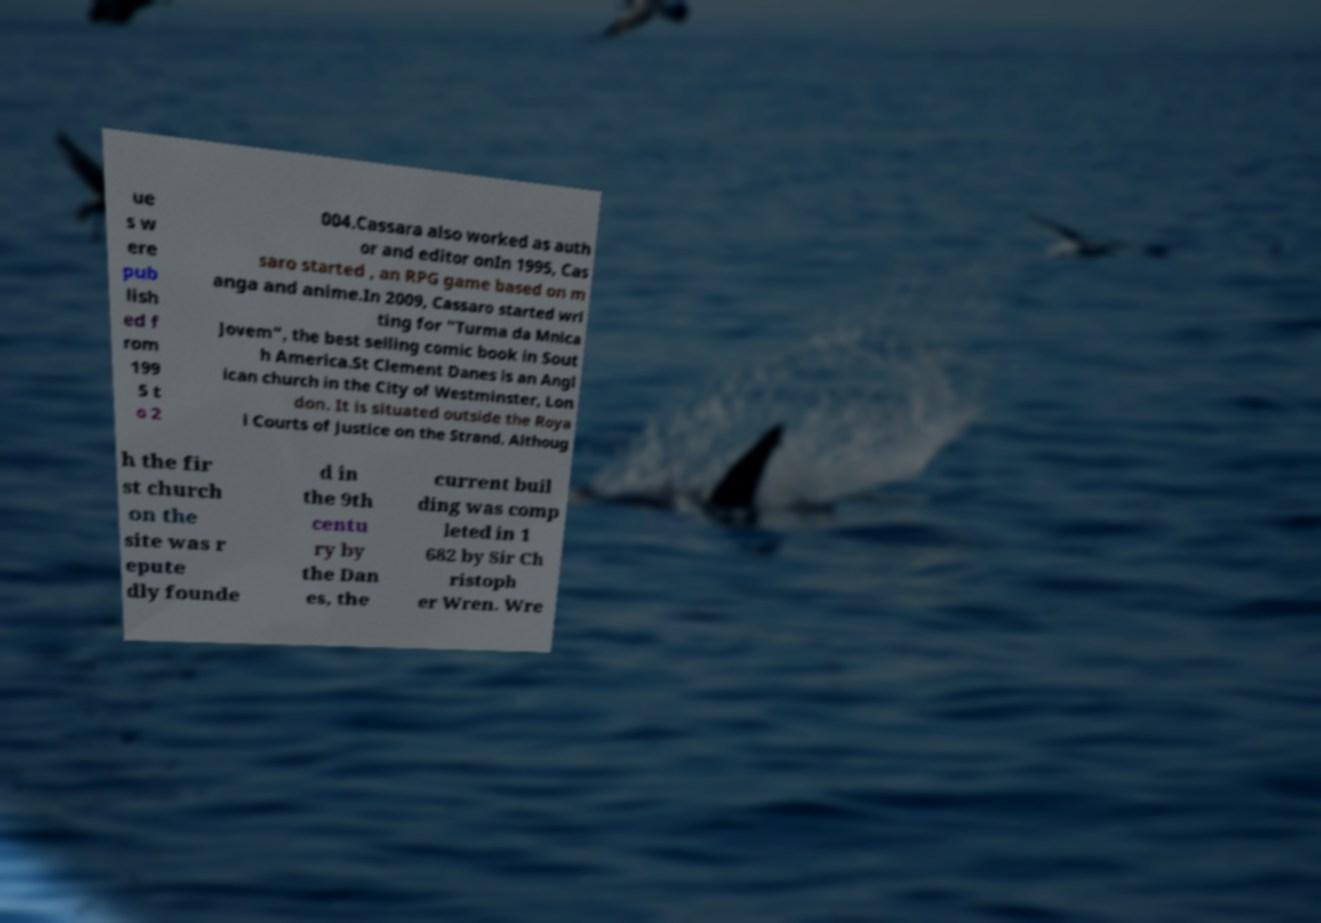Could you assist in decoding the text presented in this image and type it out clearly? ue s w ere pub lish ed f rom 199 5 t o 2 004.Cassara also worked as auth or and editor onIn 1995, Cas saro started , an RPG game based on m anga and anime.In 2009, Cassaro started wri ting for "Turma da Mnica Jovem", the best selling comic book in Sout h America.St Clement Danes is an Angl ican church in the City of Westminster, Lon don. It is situated outside the Roya l Courts of Justice on the Strand. Althoug h the fir st church on the site was r epute dly founde d in the 9th centu ry by the Dan es, the current buil ding was comp leted in 1 682 by Sir Ch ristoph er Wren. Wre 